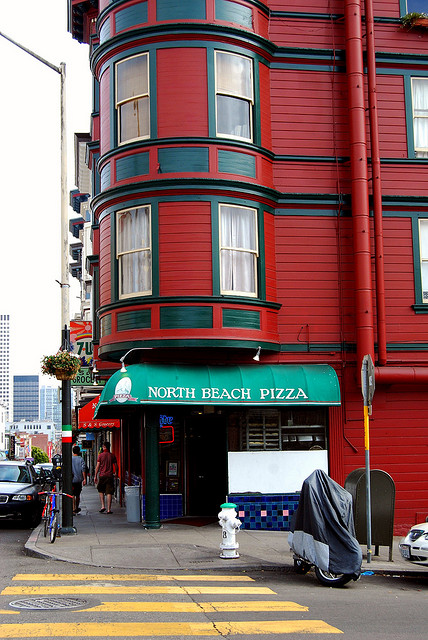Identify the text contained in this image. NORTH BEACH PIZZA 7U 